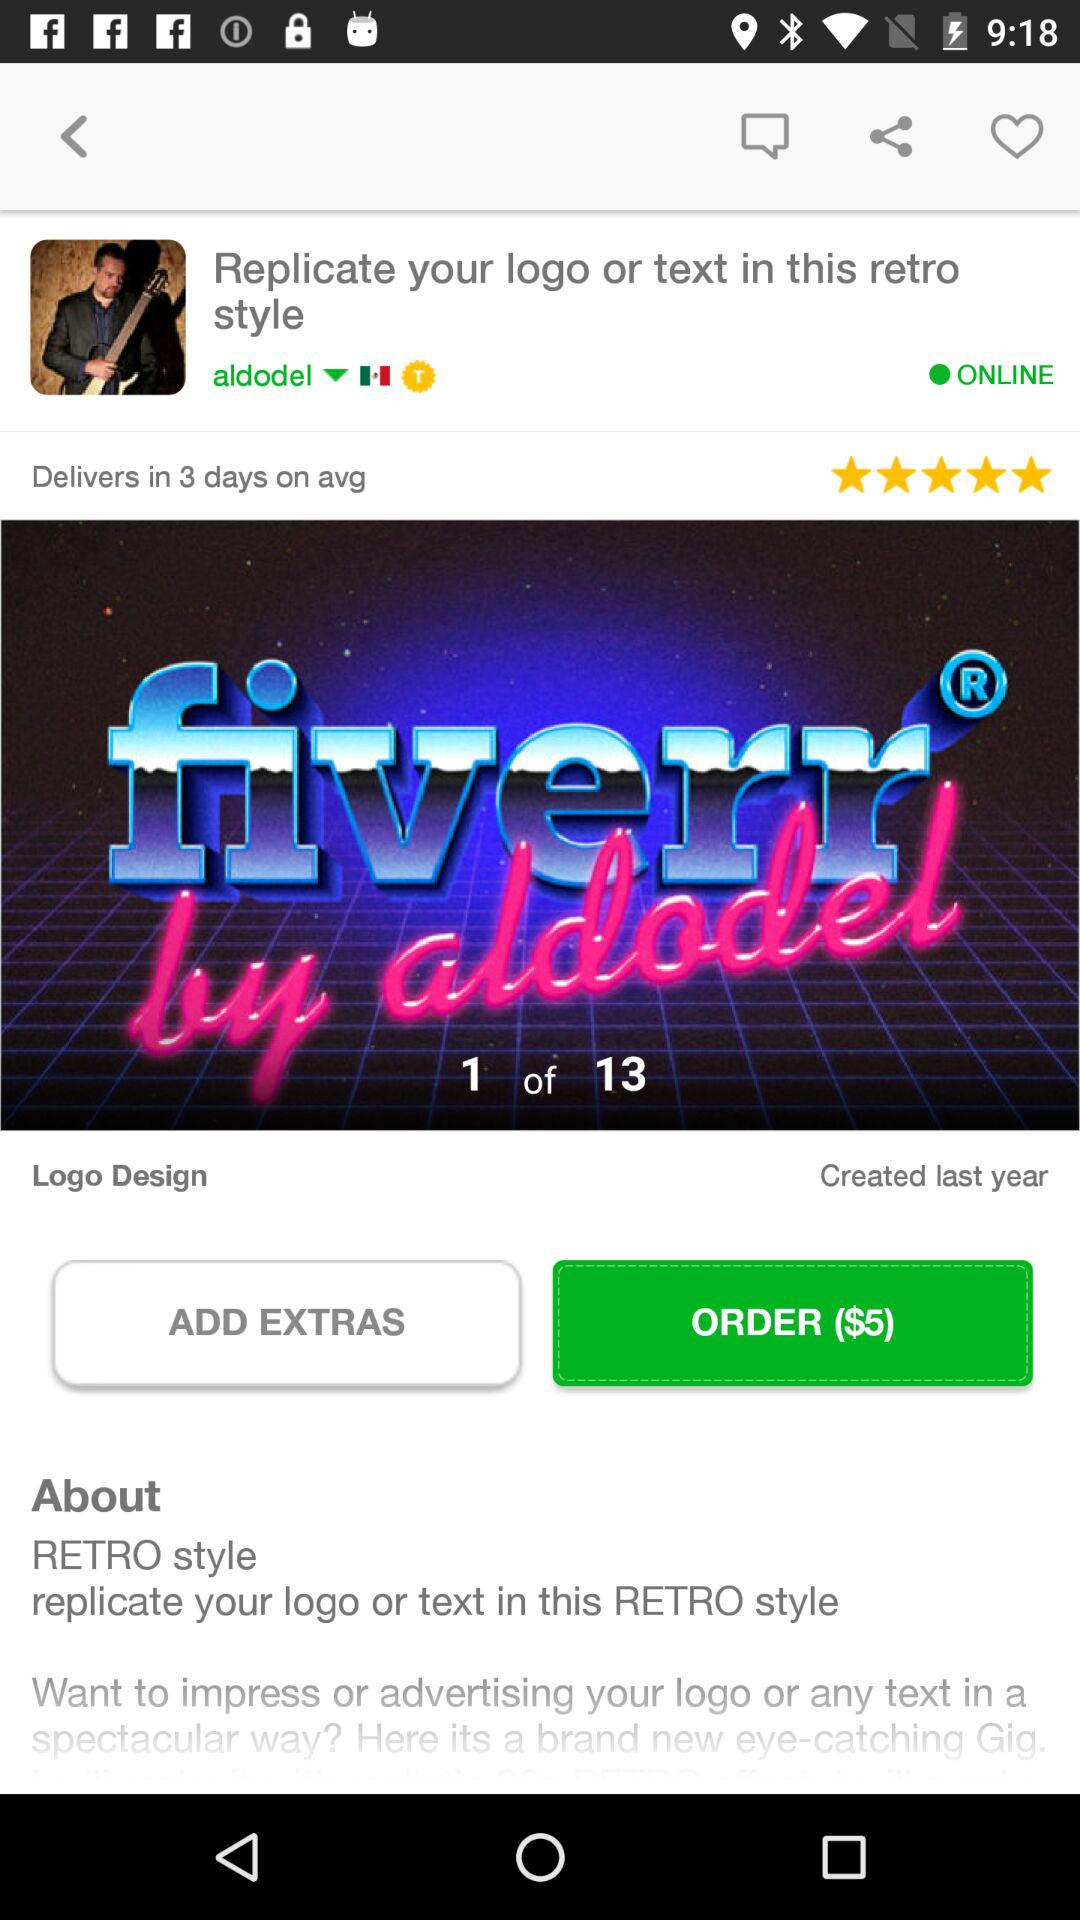What is the price of the order? The price of the order is $5. 